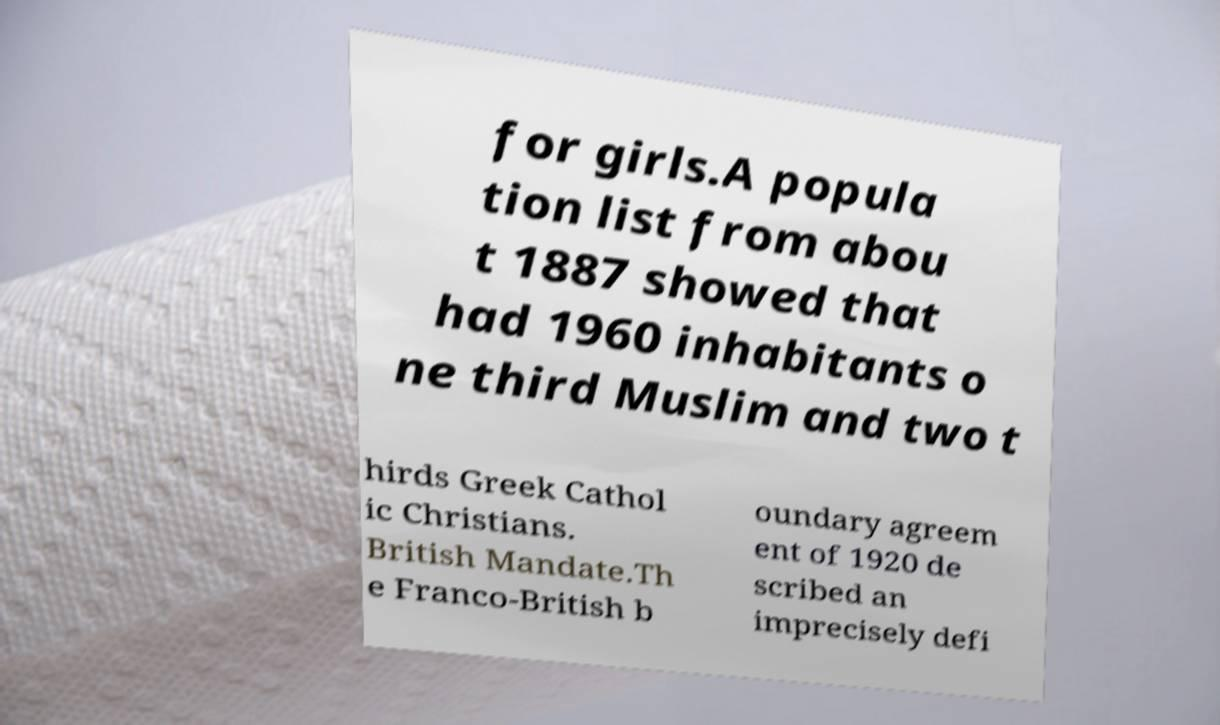Please identify and transcribe the text found in this image. for girls.A popula tion list from abou t 1887 showed that had 1960 inhabitants o ne third Muslim and two t hirds Greek Cathol ic Christians. British Mandate.Th e Franco-British b oundary agreem ent of 1920 de scribed an imprecisely defi 